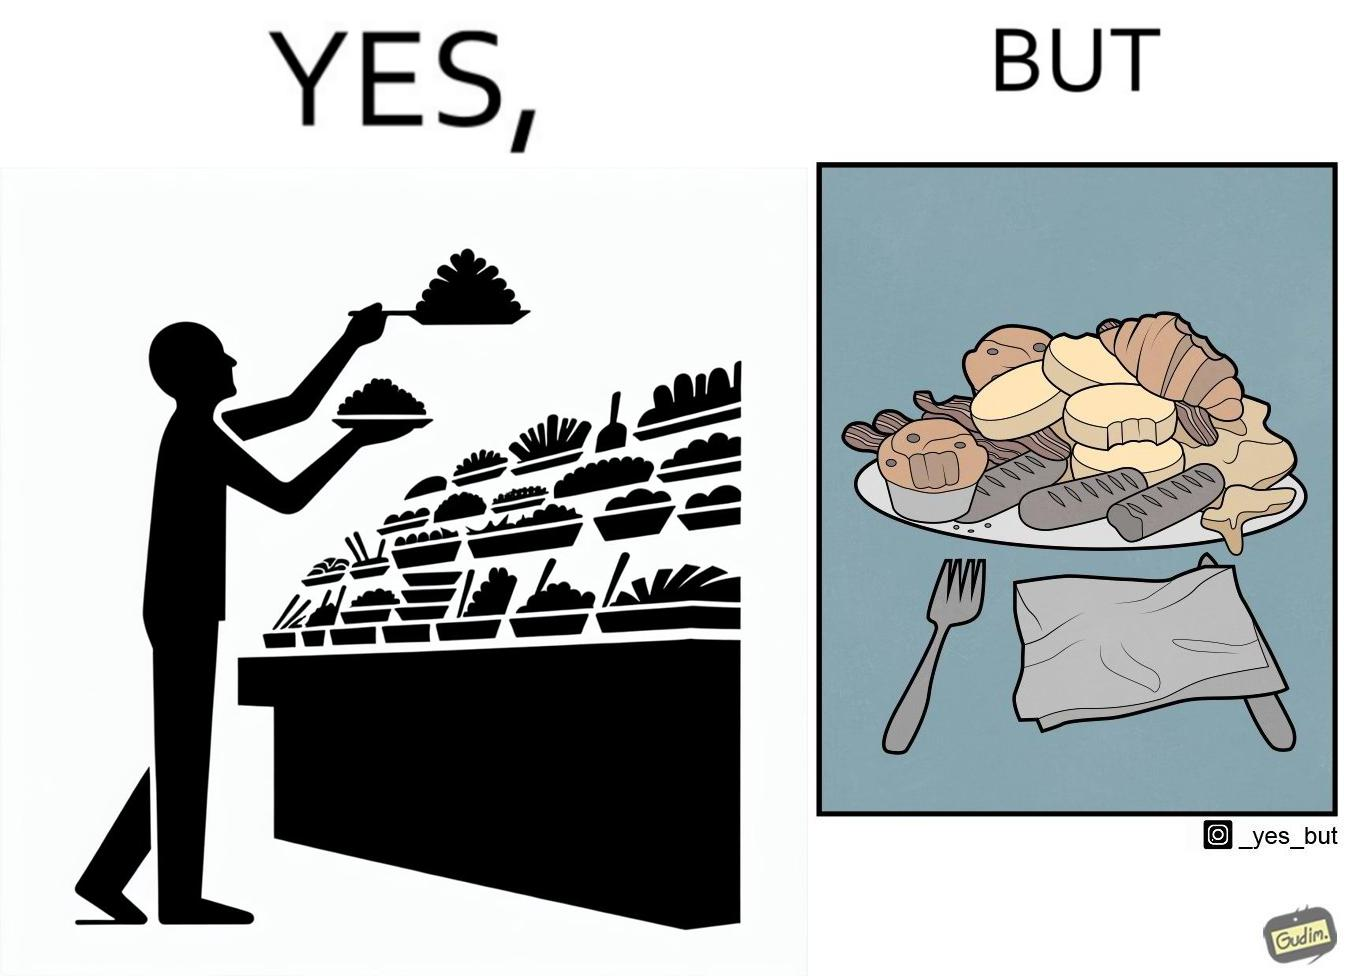Describe the satirical element in this image. The image is satirical because while the man overfils his plate with differnt food items, he ends up wasting almost all of it by not eating them or by taking just one bite out of them leaving the rest. 